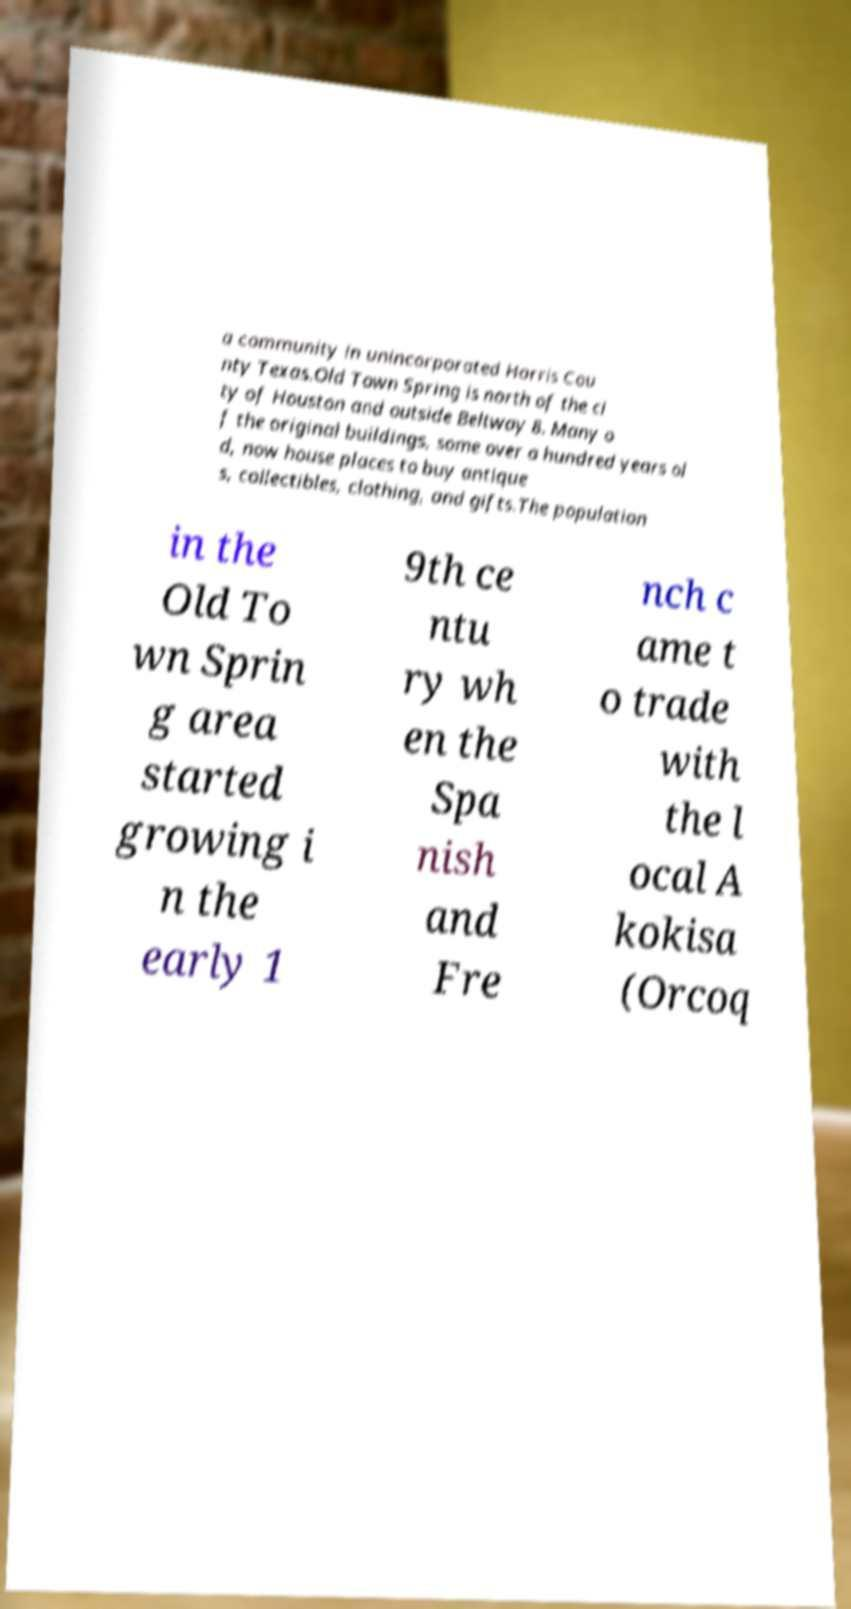Could you assist in decoding the text presented in this image and type it out clearly? a community in unincorporated Harris Cou nty Texas.Old Town Spring is north of the ci ty of Houston and outside Beltway 8. Many o f the original buildings, some over a hundred years ol d, now house places to buy antique s, collectibles, clothing, and gifts.The population in the Old To wn Sprin g area started growing i n the early 1 9th ce ntu ry wh en the Spa nish and Fre nch c ame t o trade with the l ocal A kokisa (Orcoq 